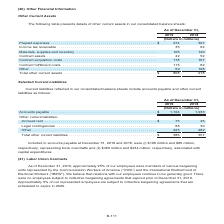According to Centurylink's financial document, What is the amount of contract assets in 2019? According to the financial document, 42 (in millions). The relevant text states: "upplies and inventory . 105 120 Contract assets . 42 52 Contract acquisition costs . 178 167 Contract fulfillment costs . 115 82 Other . 59 108..." Also, What is the amount of contract acquisition costs in 2019? According to the financial document, 178 (in millions). The relevant text states: "tract assets . 42 52 Contract acquisition costs . 178 167 Contract fulfillment costs . 115 82 Other . 59 108..." Also, What are the different segments of other current assets highlighted in the table? The document contains multiple relevant values: Prepaid expenses, Income tax receivable, Materials, supplies and inventory, Contract assets, Contract acquisition costs, Contract fulfillment costs, Other. From the document: "(Dollars in millions) Prepaid expenses . $ 274 307 Income tax receivable . 35 82 Materials, supplies and inventory . 105 120 Contract asse xpenses . $..." Additionally, Which year has a larger amount of contract acquisition costs? According to the financial document, 2019. The relevant text states: "As of December 31, 2019 2018..." Also, can you calculate: What is the change in contract assets in 2019? Based on the calculation: 42-52, the result is -10 (in millions). This is based on the information: "upplies and inventory . 105 120 Contract assets . 42 52 Contract acquisition costs . 178 167 Contract fulfillment costs . 115 82 Other . 59 108 lies and inventory . 105 120 Contract assets . 42 52 Con..." The key data points involved are: 42, 52. Also, can you calculate: What is the percentage change in total other current assets in 2019? To answer this question, I need to perform calculations using the financial data. The calculation is: (808-918)/918, which equals -11.98 (percentage). This is based on the information: "Total other current assets . $ 808 918 Total other current assets . $ 808 918..." The key data points involved are: 808, 918. 